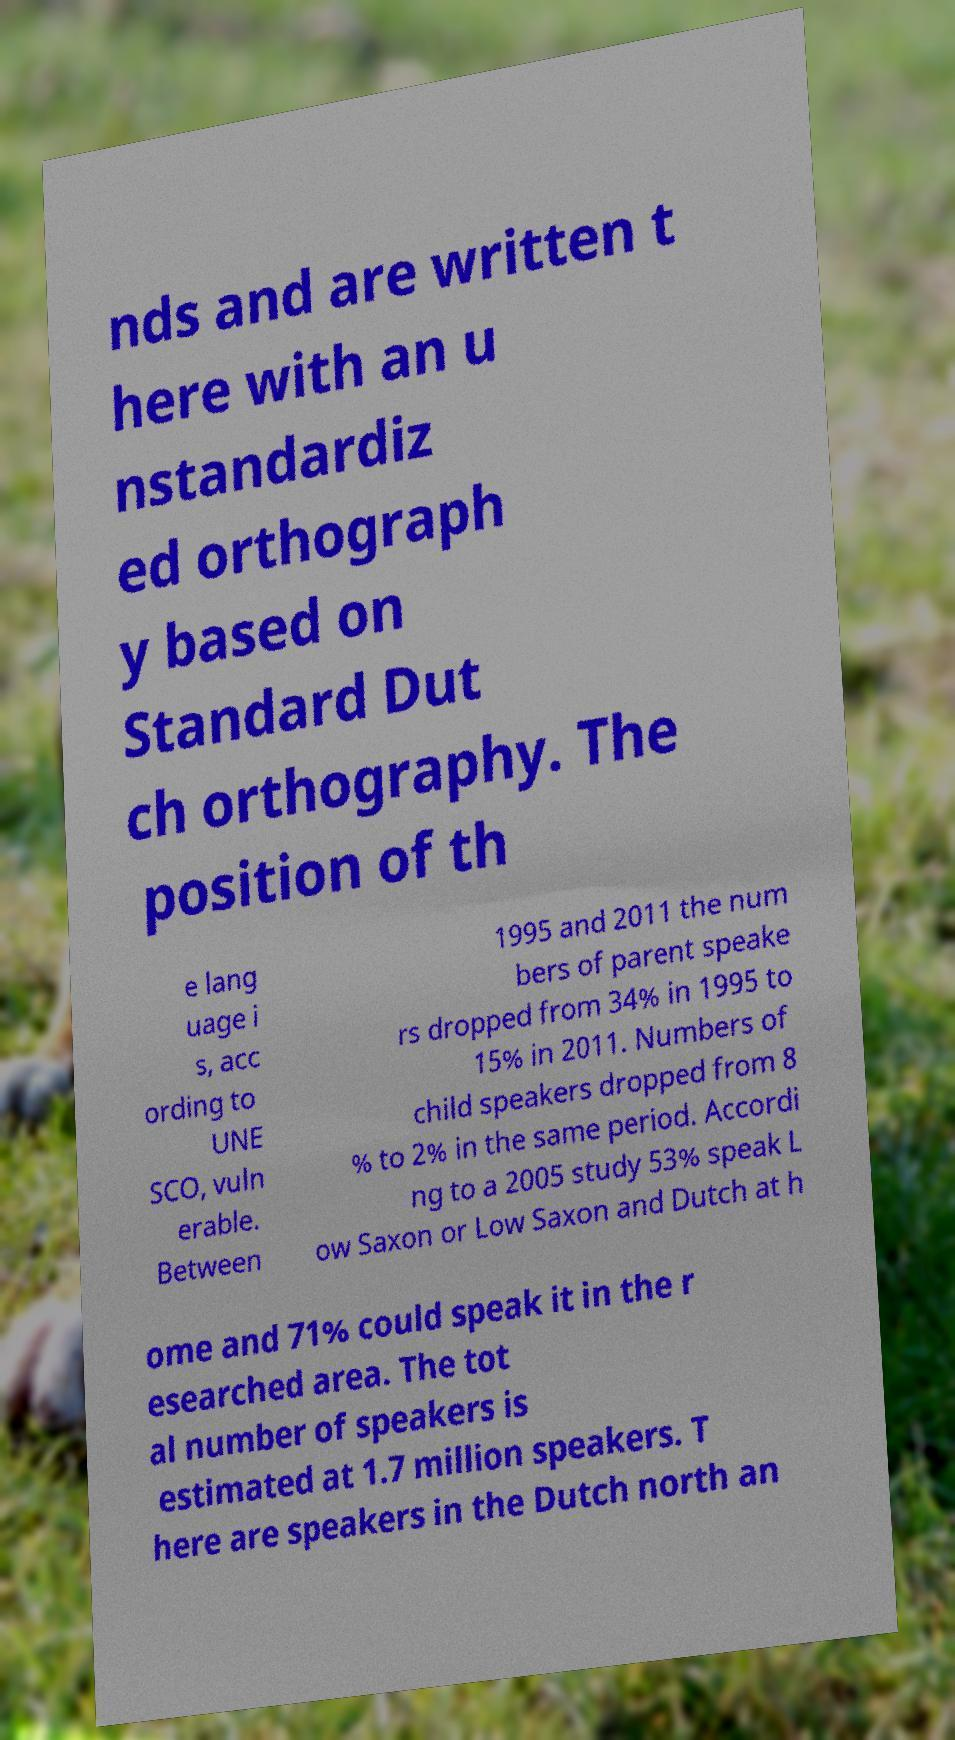Could you extract and type out the text from this image? nds and are written t here with an u nstandardiz ed orthograph y based on Standard Dut ch orthography. The position of th e lang uage i s, acc ording to UNE SCO, vuln erable. Between 1995 and 2011 the num bers of parent speake rs dropped from 34% in 1995 to 15% in 2011. Numbers of child speakers dropped from 8 % to 2% in the same period. Accordi ng to a 2005 study 53% speak L ow Saxon or Low Saxon and Dutch at h ome and 71% could speak it in the r esearched area. The tot al number of speakers is estimated at 1.7 million speakers. T here are speakers in the Dutch north an 